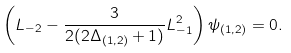Convert formula to latex. <formula><loc_0><loc_0><loc_500><loc_500>\left ( L _ { - 2 } - \frac { 3 } { 2 ( 2 \Delta _ { ( 1 , 2 ) } + 1 ) } L _ { - 1 } ^ { 2 } \right ) \psi _ { ( 1 , 2 ) } = 0 .</formula> 